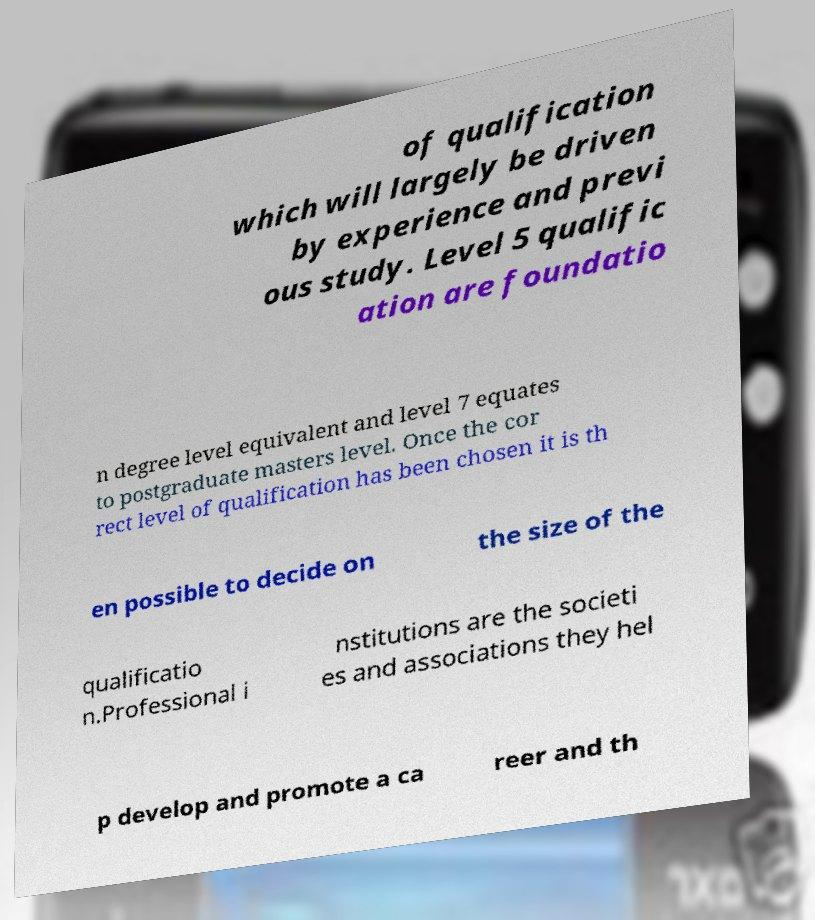Can you read and provide the text displayed in the image?This photo seems to have some interesting text. Can you extract and type it out for me? of qualification which will largely be driven by experience and previ ous study. Level 5 qualific ation are foundatio n degree level equivalent and level 7 equates to postgraduate masters level. Once the cor rect level of qualification has been chosen it is th en possible to decide on the size of the qualificatio n.Professional i nstitutions are the societi es and associations they hel p develop and promote a ca reer and th 